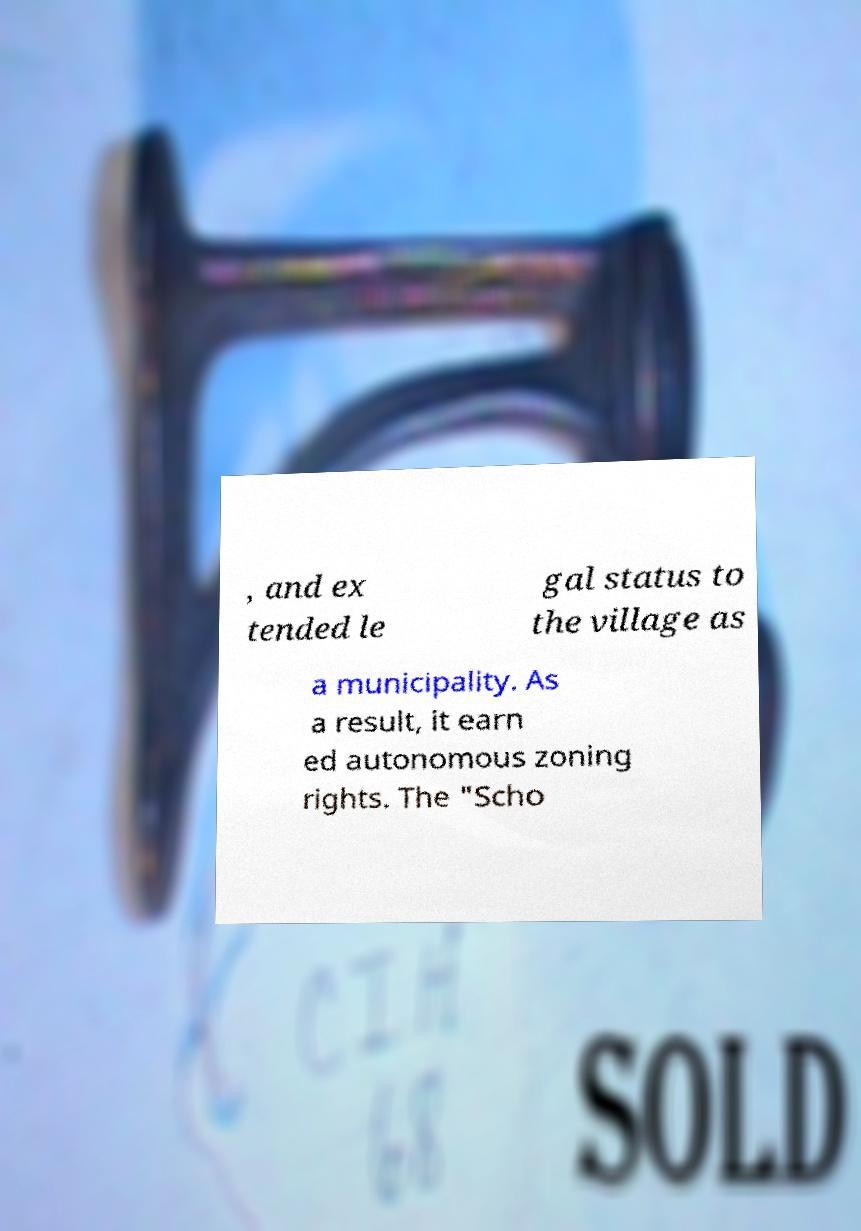There's text embedded in this image that I need extracted. Can you transcribe it verbatim? , and ex tended le gal status to the village as a municipality. As a result, it earn ed autonomous zoning rights. The "Scho 